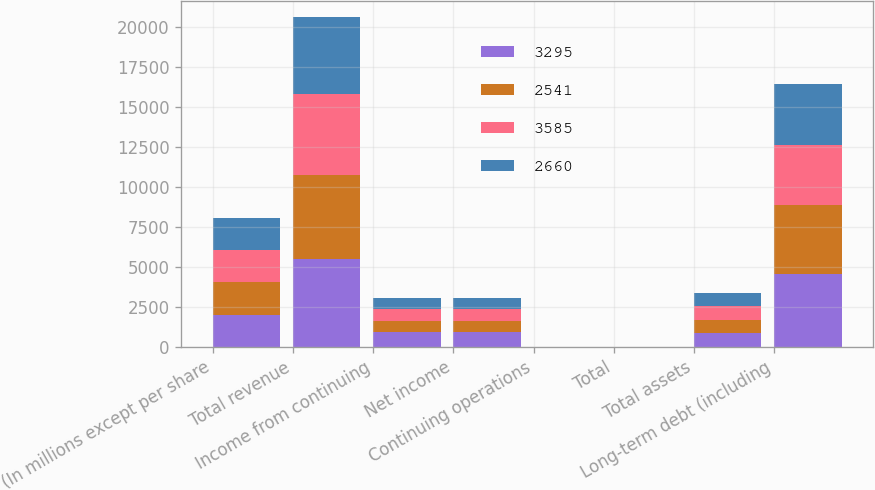<chart> <loc_0><loc_0><loc_500><loc_500><stacked_bar_chart><ecel><fcel>(In millions except per share<fcel>Total revenue<fcel>Income from continuing<fcel>Net income<fcel>Continuing operations<fcel>Total<fcel>Total assets<fcel>Long-term debt (including<nl><fcel>3295<fcel>2016<fcel>5505<fcel>930<fcel>930<fcel>4.22<fcel>4.22<fcel>842<fcel>4562<nl><fcel>2541<fcel>2015<fcel>5254<fcel>712<fcel>712<fcel>3.04<fcel>3.04<fcel>842<fcel>4293<nl><fcel>3585<fcel>2014<fcel>5066<fcel>754<fcel>754<fcel>3.04<fcel>3.03<fcel>842<fcel>3790<nl><fcel>2660<fcel>2013<fcel>4814<fcel>650<fcel>648<fcel>2.48<fcel>2.47<fcel>842<fcel>3831<nl></chart> 